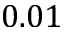<formula> <loc_0><loc_0><loc_500><loc_500>0 . 0 1</formula> 